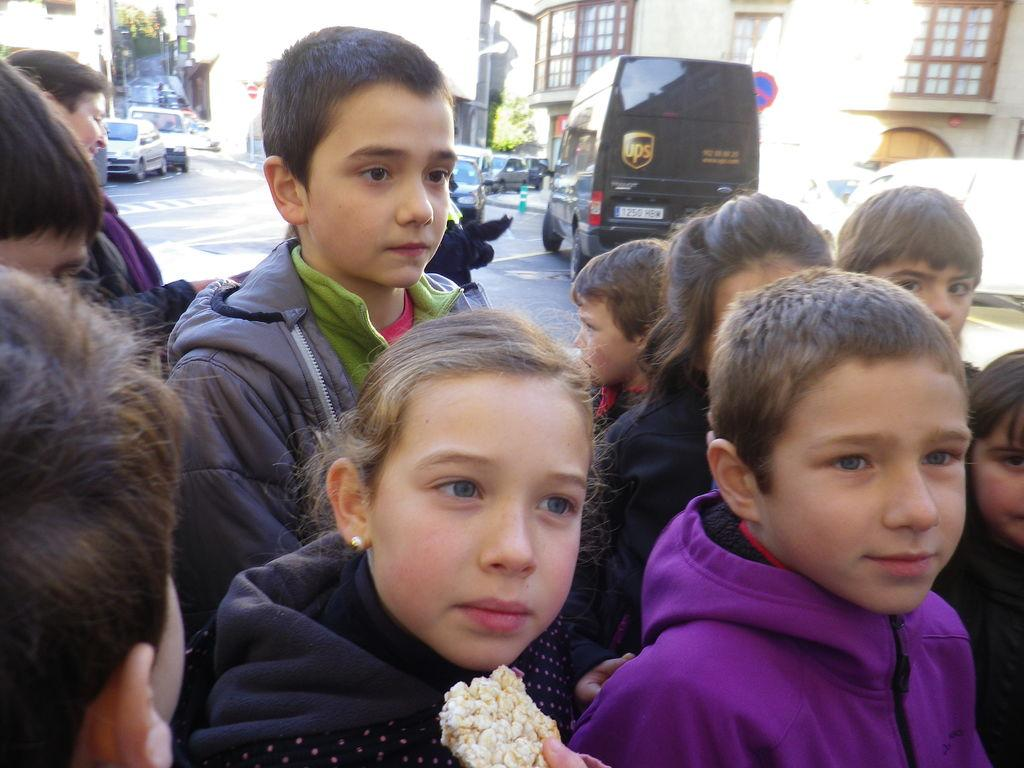How many people are in the group visible in the image? There is a group of people in the image, but the exact number is not specified. What can be seen in the background of the image? In the background of the image, there are vehicles on the road, buildings, signboards, trees, and some unspecified objects. What type of objects are present in the background of the image? The unspecified objects in the background of the image could be anything, but we cannot determine their nature from the provided facts. What type of treatment is being administered to the river in the image? There is no river present in the image, so no treatment can be administered to it. 